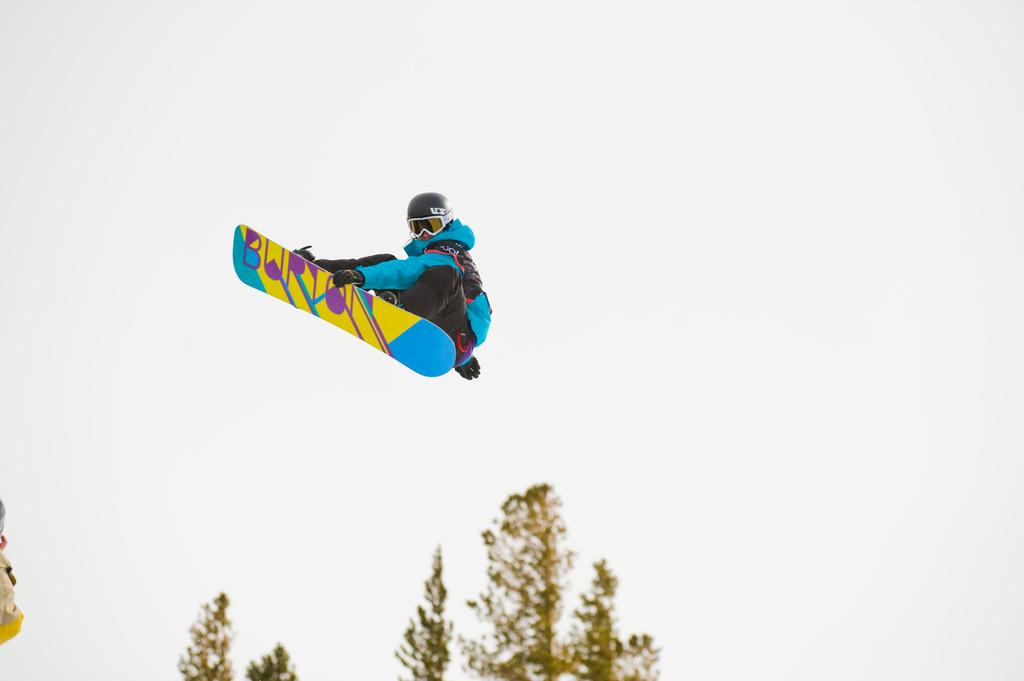What is the person in the image doing? The person is skating in the air. What else can be seen in the image besides the person skating? There are a few trees in the image. What is visible in the background of the image? The sky is visible in the image. What type of ground is the person skating on in the image? The person is not skating on the ground; they are skating in the air. What is the base of the trees in the image made of? The provided facts do not mention the base of the trees or their material, so we cannot determine that information from the image. 